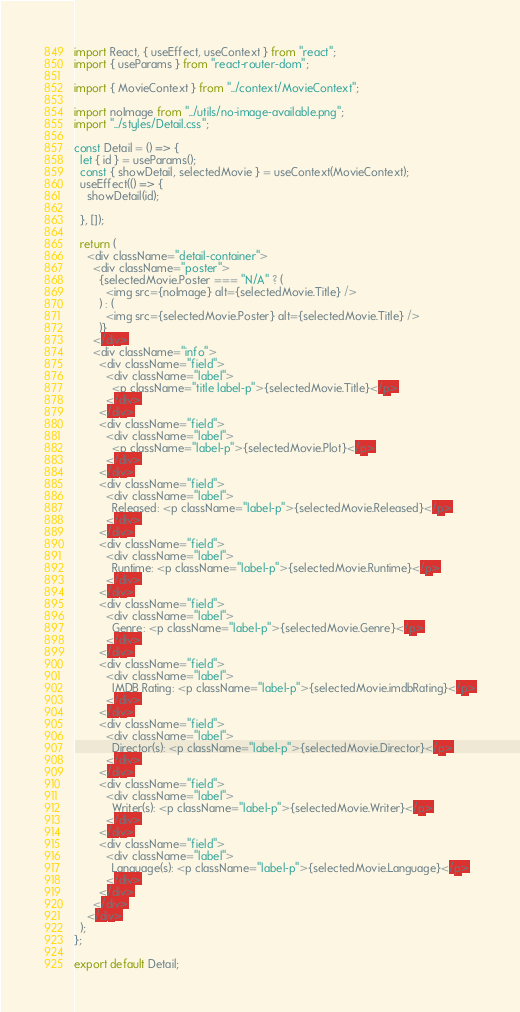<code> <loc_0><loc_0><loc_500><loc_500><_JavaScript_>import React, { useEffect, useContext } from "react";
import { useParams } from "react-router-dom";

import { MovieContext } from "../context/MovieContext";

import noImage from "../utils/no-image-available.png";
import "../styles/Detail.css";

const Detail = () => {
  let { id } = useParams();
  const { showDetail, selectedMovie } = useContext(MovieContext);
  useEffect(() => {
    showDetail(id);
  
  }, []);

  return (
    <div className="detail-container">
      <div className="poster">
        {selectedMovie.Poster === "N/A" ? (
          <img src={noImage} alt={selectedMovie.Title} />
        ) : (
          <img src={selectedMovie.Poster} alt={selectedMovie.Title} />
        )}
      </div>
      <div className="info">
        <div className="field">
          <div className="label">
            <p className="title label-p">{selectedMovie.Title}</p>
          </div>
        </div>
        <div className="field">
          <div className="label">
            <p className="label-p">{selectedMovie.Plot}</p>
          </div>
        </div>
        <div className="field">
          <div className="label">
            Released: <p className="label-p">{selectedMovie.Released}</p>
          </div>
        </div>
        <div className="field">
          <div className="label">
            Runtime: <p className="label-p">{selectedMovie.Runtime}</p>
          </div>
        </div>
        <div className="field">
          <div className="label">
            Genre: <p className="label-p">{selectedMovie.Genre}</p>
          </div>
        </div>
        <div className="field">
          <div className="label">
            IMDB Rating: <p className="label-p">{selectedMovie.imdbRating}</p>
          </div>
        </div>
        <div className="field">
          <div className="label">
            Director(s): <p className="label-p">{selectedMovie.Director}</p>
          </div>
        </div>
        <div className="field">
          <div className="label">
            Writer(s): <p className="label-p">{selectedMovie.Writer}</p>
          </div>
        </div>
        <div className="field">
          <div className="label">
            Language(s): <p className="label-p">{selectedMovie.Language}</p>
          </div>
        </div>
      </div>
    </div>
  );
};

export default Detail;
</code> 